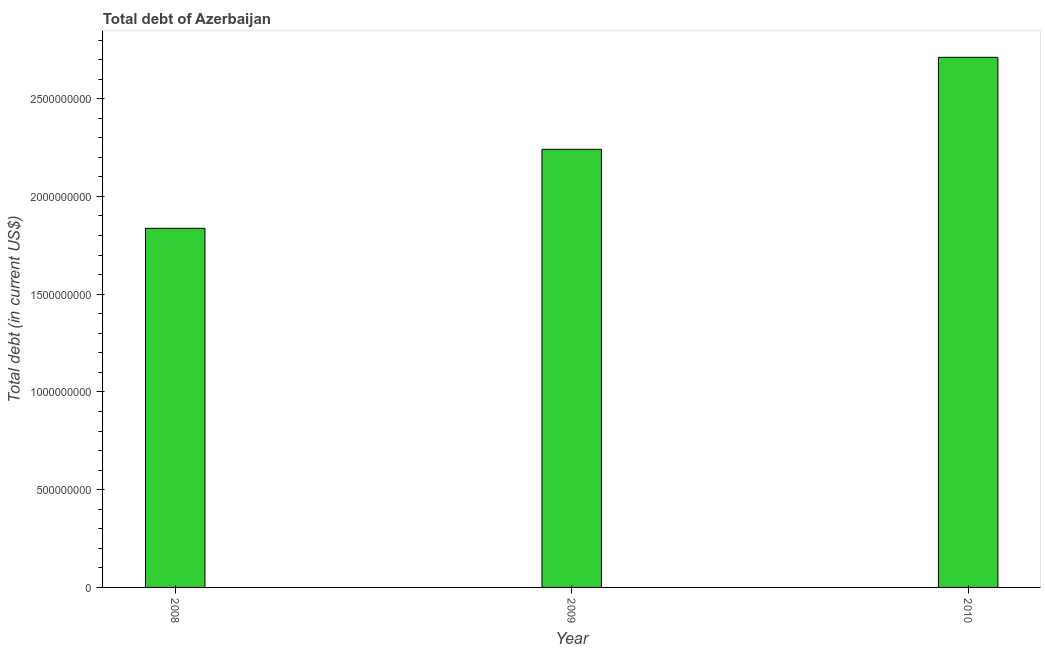Does the graph contain any zero values?
Your response must be concise. No. What is the title of the graph?
Make the answer very short. Total debt of Azerbaijan. What is the label or title of the X-axis?
Make the answer very short. Year. What is the label or title of the Y-axis?
Provide a succinct answer. Total debt (in current US$). What is the total debt in 2010?
Give a very brief answer. 2.71e+09. Across all years, what is the maximum total debt?
Offer a very short reply. 2.71e+09. Across all years, what is the minimum total debt?
Make the answer very short. 1.84e+09. In which year was the total debt maximum?
Provide a succinct answer. 2010. What is the sum of the total debt?
Your answer should be very brief. 6.79e+09. What is the difference between the total debt in 2009 and 2010?
Your answer should be very brief. -4.71e+08. What is the average total debt per year?
Your response must be concise. 2.26e+09. What is the median total debt?
Your answer should be very brief. 2.24e+09. In how many years, is the total debt greater than 1800000000 US$?
Your answer should be compact. 3. Do a majority of the years between 2008 and 2009 (inclusive) have total debt greater than 100000000 US$?
Offer a very short reply. Yes. What is the ratio of the total debt in 2008 to that in 2009?
Give a very brief answer. 0.82. Is the difference between the total debt in 2008 and 2009 greater than the difference between any two years?
Make the answer very short. No. What is the difference between the highest and the second highest total debt?
Your answer should be very brief. 4.71e+08. Is the sum of the total debt in 2009 and 2010 greater than the maximum total debt across all years?
Ensure brevity in your answer.  Yes. What is the difference between the highest and the lowest total debt?
Offer a terse response. 8.75e+08. How many bars are there?
Your answer should be very brief. 3. How many years are there in the graph?
Offer a terse response. 3. What is the difference between two consecutive major ticks on the Y-axis?
Provide a succinct answer. 5.00e+08. What is the Total debt (in current US$) of 2008?
Make the answer very short. 1.84e+09. What is the Total debt (in current US$) of 2009?
Your answer should be very brief. 2.24e+09. What is the Total debt (in current US$) of 2010?
Your answer should be very brief. 2.71e+09. What is the difference between the Total debt (in current US$) in 2008 and 2009?
Ensure brevity in your answer.  -4.04e+08. What is the difference between the Total debt (in current US$) in 2008 and 2010?
Your answer should be compact. -8.75e+08. What is the difference between the Total debt (in current US$) in 2009 and 2010?
Keep it short and to the point. -4.71e+08. What is the ratio of the Total debt (in current US$) in 2008 to that in 2009?
Offer a very short reply. 0.82. What is the ratio of the Total debt (in current US$) in 2008 to that in 2010?
Provide a short and direct response. 0.68. What is the ratio of the Total debt (in current US$) in 2009 to that in 2010?
Your answer should be very brief. 0.83. 